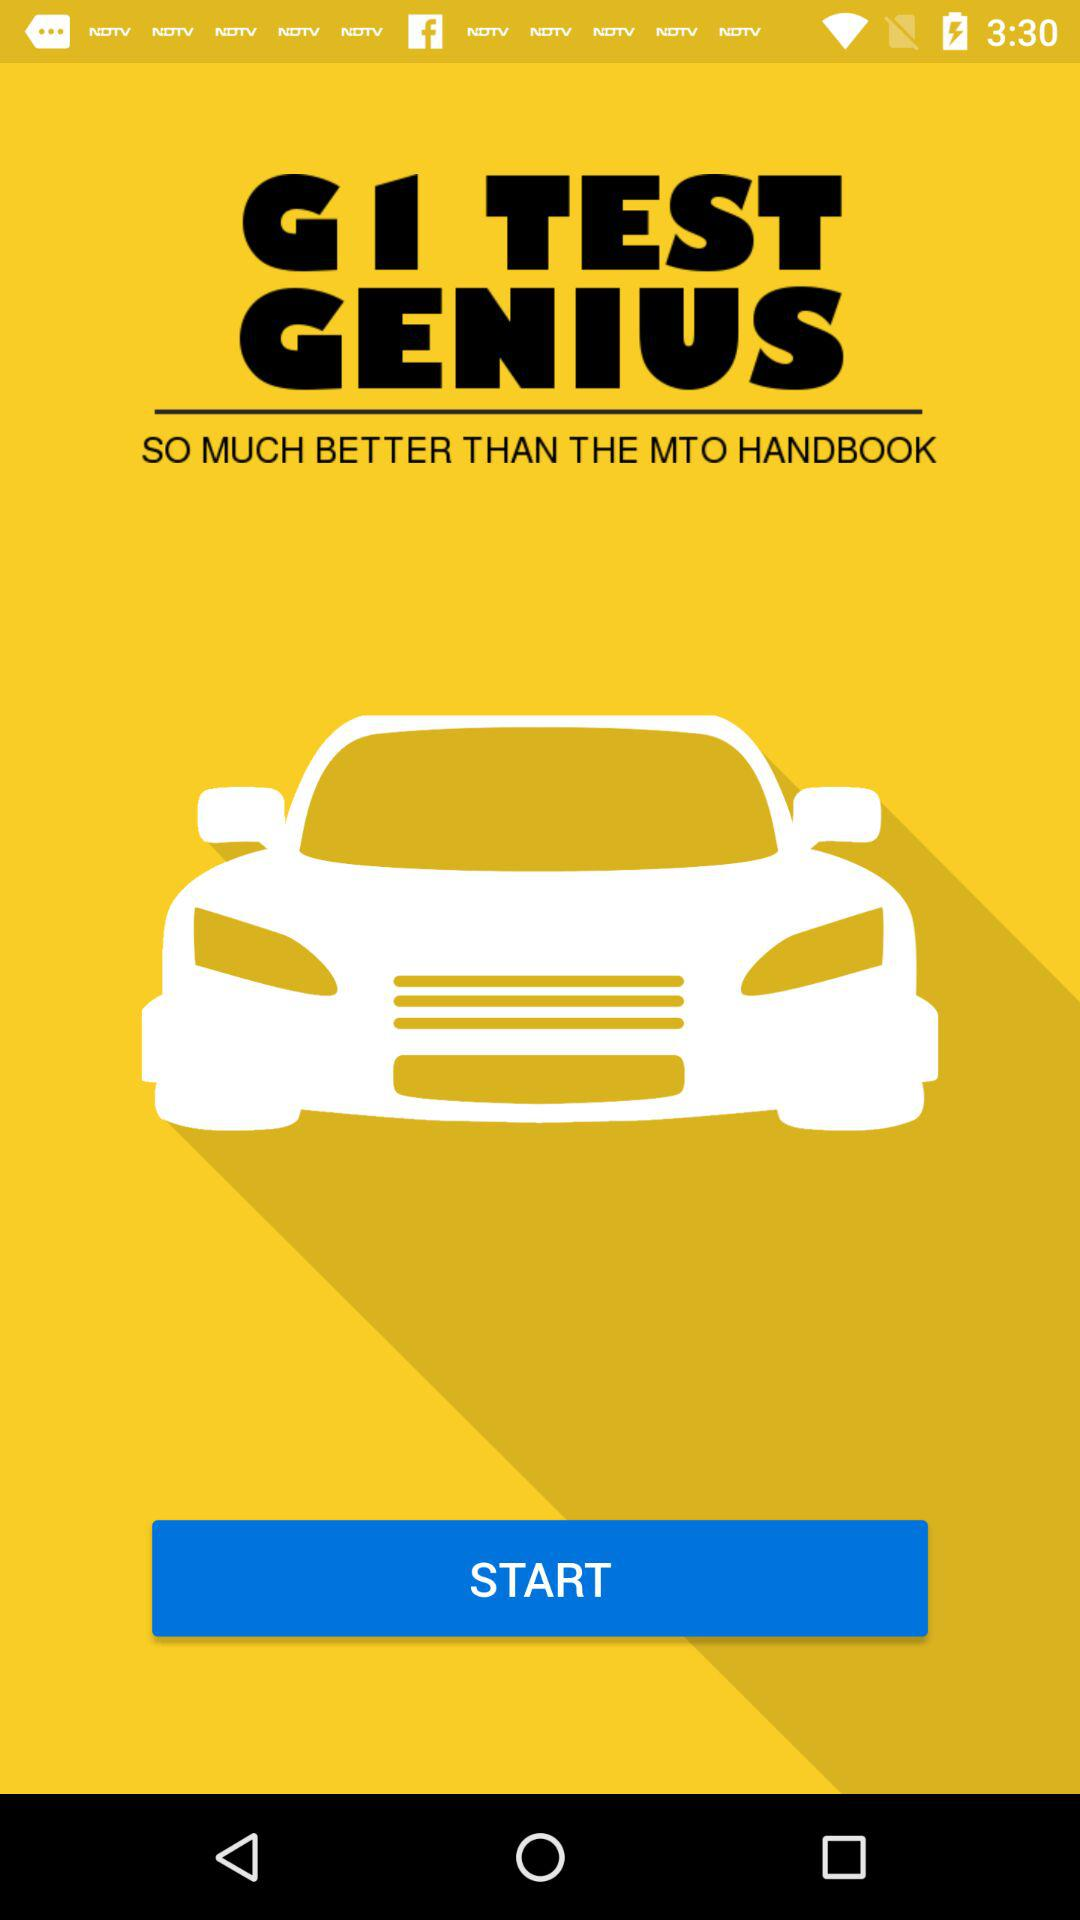What is the name of the application? The name of the application is "GI TEST GENIUS". 